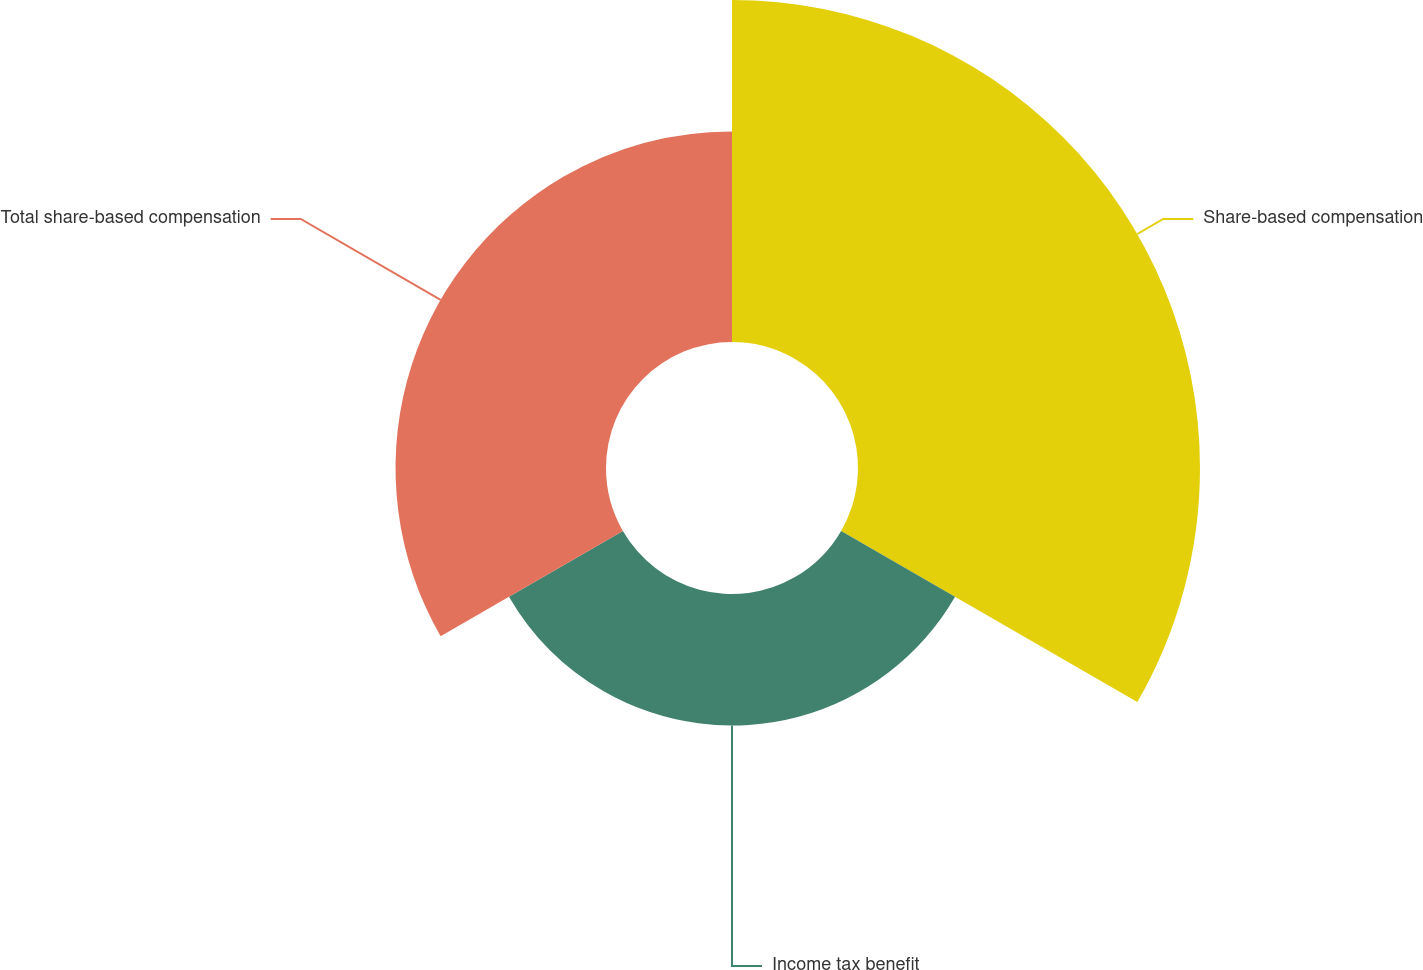Convert chart to OTSL. <chart><loc_0><loc_0><loc_500><loc_500><pie_chart><fcel>Share-based compensation<fcel>Income tax benefit<fcel>Total share-based compensation<nl><fcel>50.0%<fcel>19.23%<fcel>30.77%<nl></chart> 